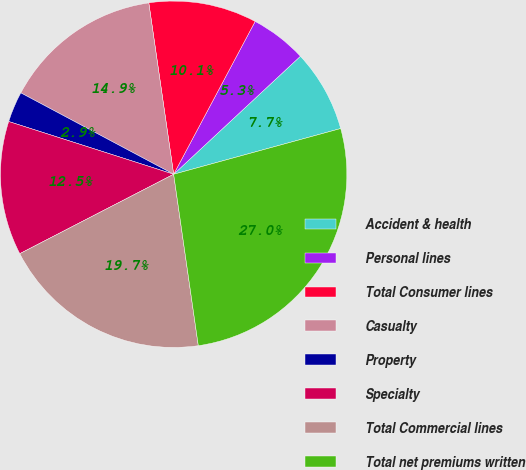<chart> <loc_0><loc_0><loc_500><loc_500><pie_chart><fcel>Accident & health<fcel>Personal lines<fcel>Total Consumer lines<fcel>Casualty<fcel>Property<fcel>Specialty<fcel>Total Commercial lines<fcel>Total net premiums written<nl><fcel>7.68%<fcel>5.27%<fcel>10.09%<fcel>14.92%<fcel>2.86%<fcel>12.51%<fcel>19.69%<fcel>26.98%<nl></chart> 